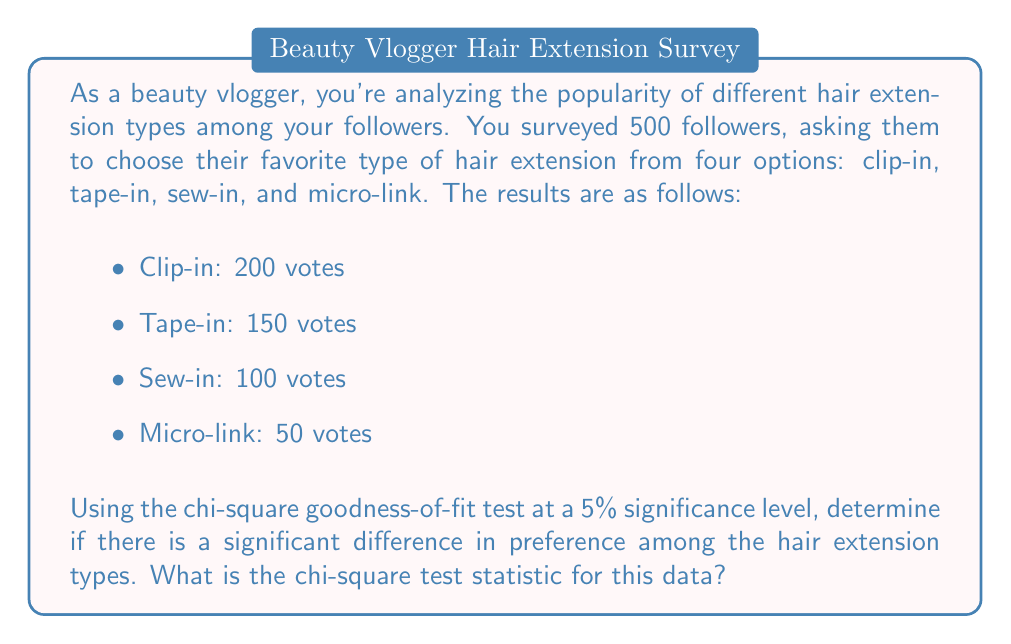Can you solve this math problem? To solve this problem, we'll use the chi-square goodness-of-fit test. The steps are as follows:

1. Set up the null and alternative hypotheses:
   $H_0$: There is no significant difference in preference among the hair extension types.
   $H_a$: There is a significant difference in preference among the hair extension types.

2. Calculate the expected frequencies:
   If there were no preference, we'd expect an equal distribution among the four types.
   Expected frequency for each type = Total sample size / Number of categories
   $E = 500 / 4 = 125$

3. Calculate the chi-square test statistic using the formula:
   $$\chi^2 = \sum_{i=1}^{k} \frac{(O_i - E_i)^2}{E_i}$$
   where $O_i$ is the observed frequency and $E_i$ is the expected frequency for each category.

4. Plug in the values:
   $$\begin{align}
   \chi^2 &= \frac{(200 - 125)^2}{125} + \frac{(150 - 125)^2}{125} + \frac{(100 - 125)^2}{125} + \frac{(50 - 125)^2}{125} \\
   &= \frac{75^2}{125} + \frac{25^2}{125} + \frac{(-25)^2}{125} + \frac{(-75)^2}{125} \\
   &= 45 + 5 + 5 + 45 \\
   &= 100
   \end{align}$$

5. The degrees of freedom (df) for this test is the number of categories minus 1:
   df = 4 - 1 = 3

6. At a 5% significance level with 3 degrees of freedom, the critical value is 7.815.

7. Since our calculated chi-square value (100) is greater than the critical value (7.815), we would reject the null hypothesis.

This suggests that there is a significant difference in preference among the hair extension types.
Answer: The chi-square test statistic is 100. 